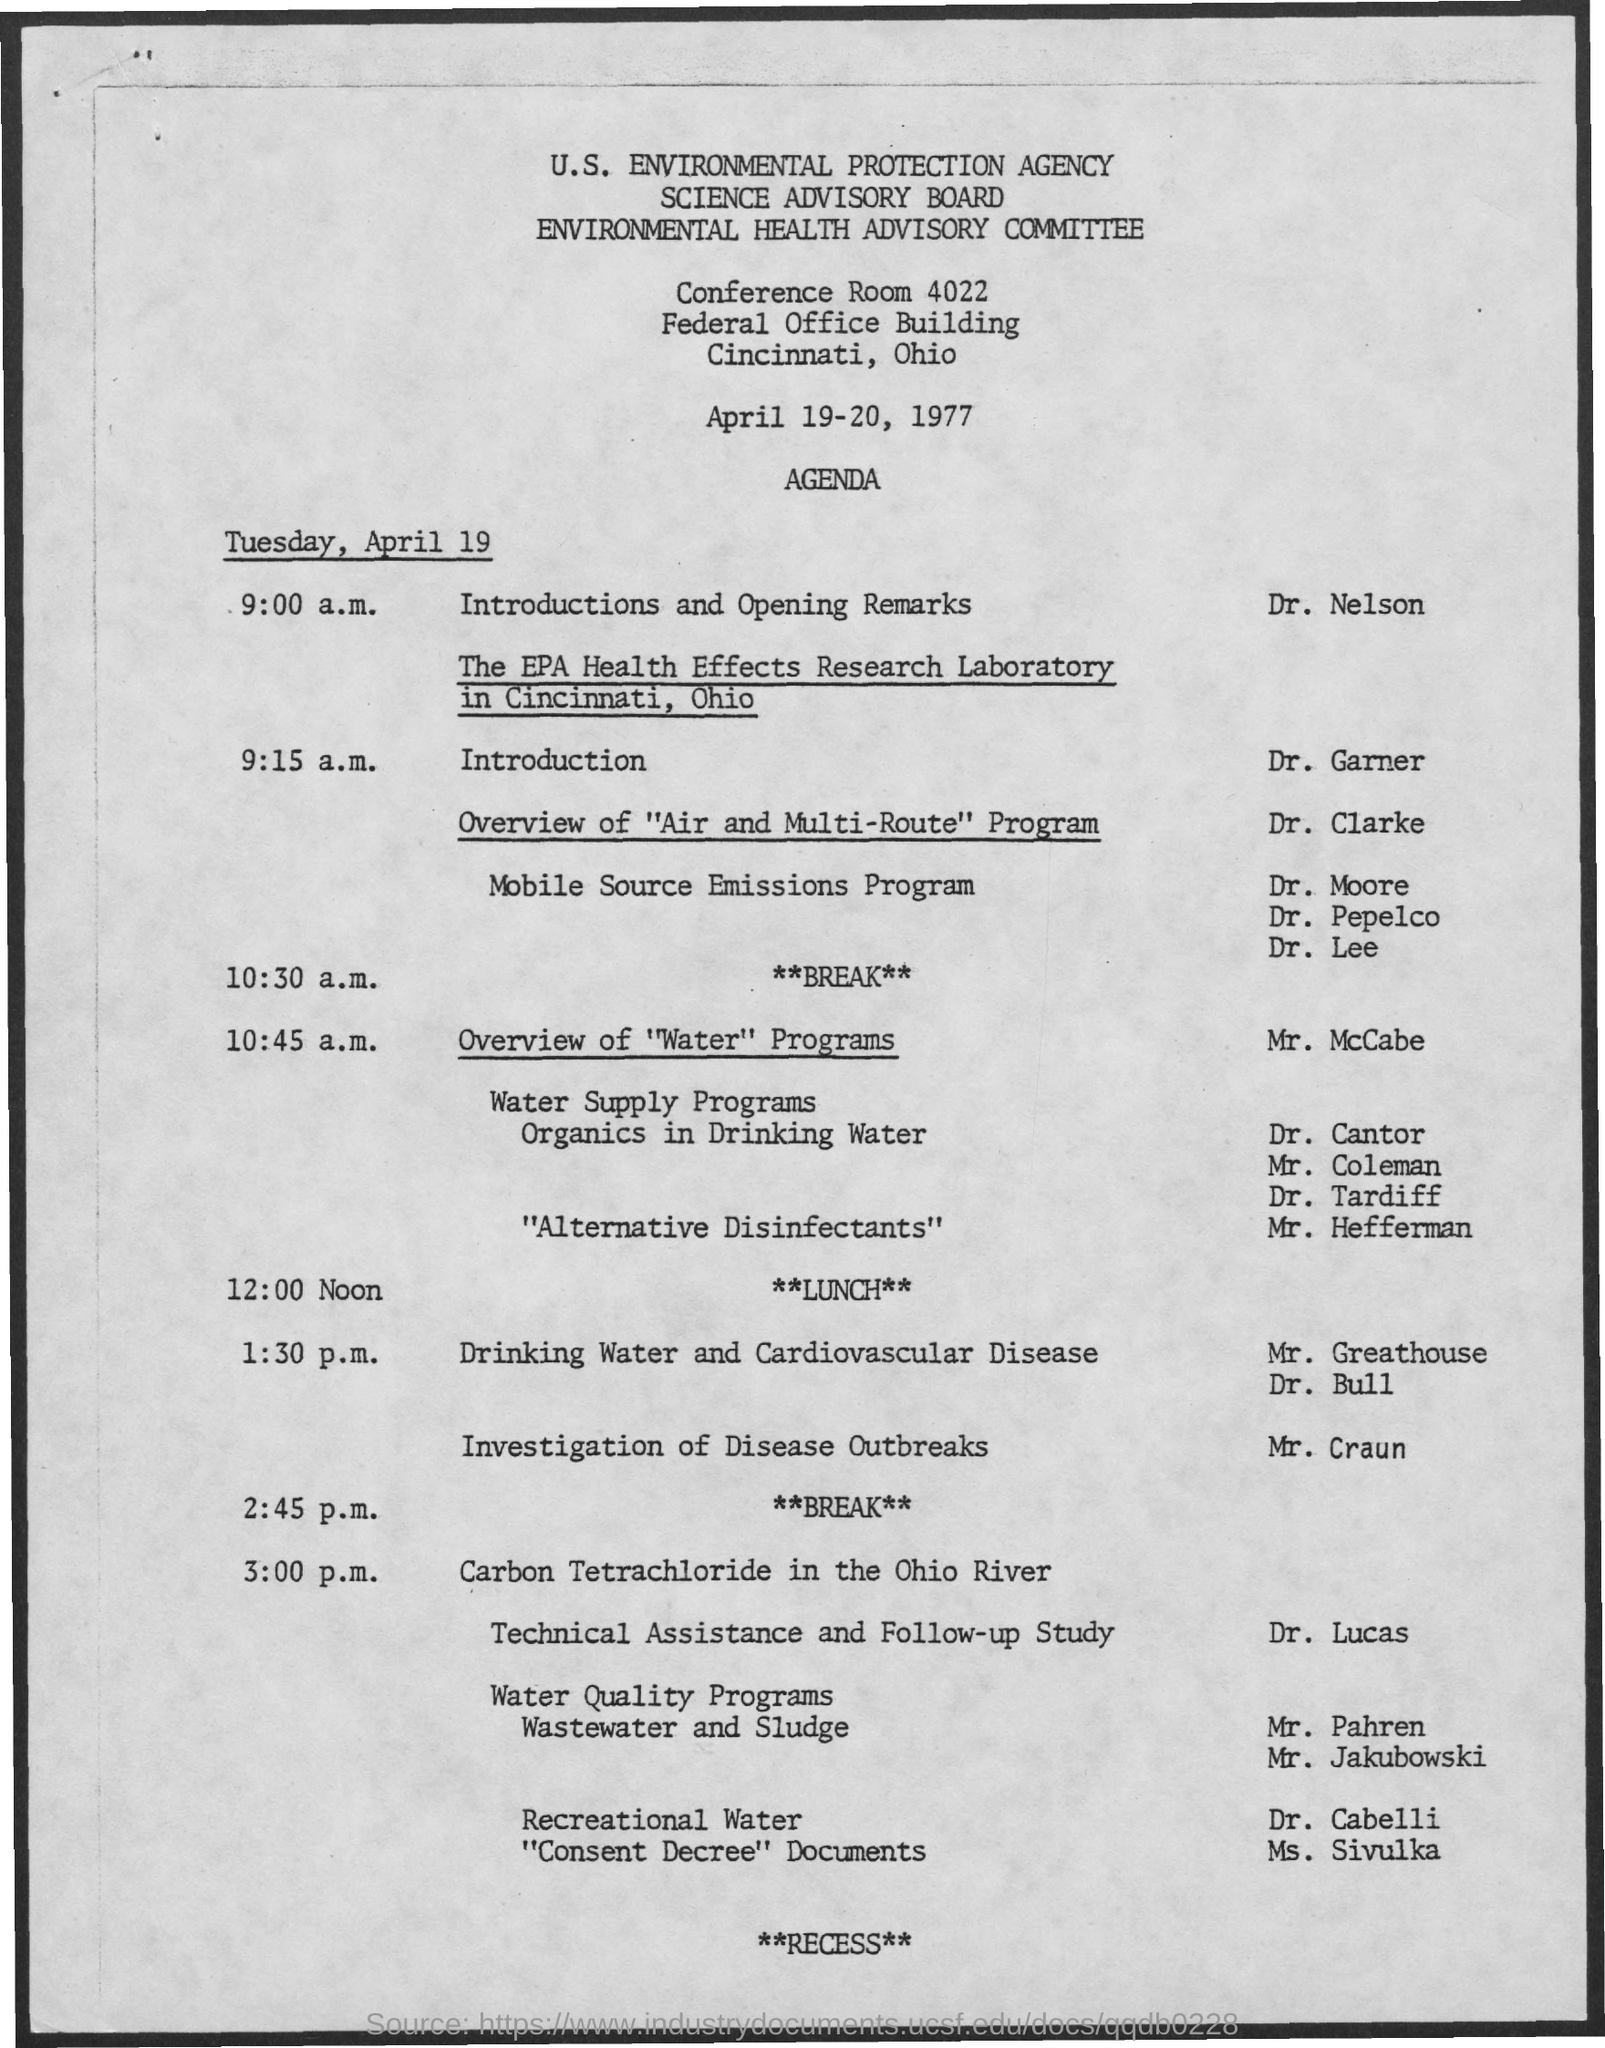Mention a couple of crucial points in this snapshot. The presenter of the Introduction and opening remarks is Dr. Nelson. 